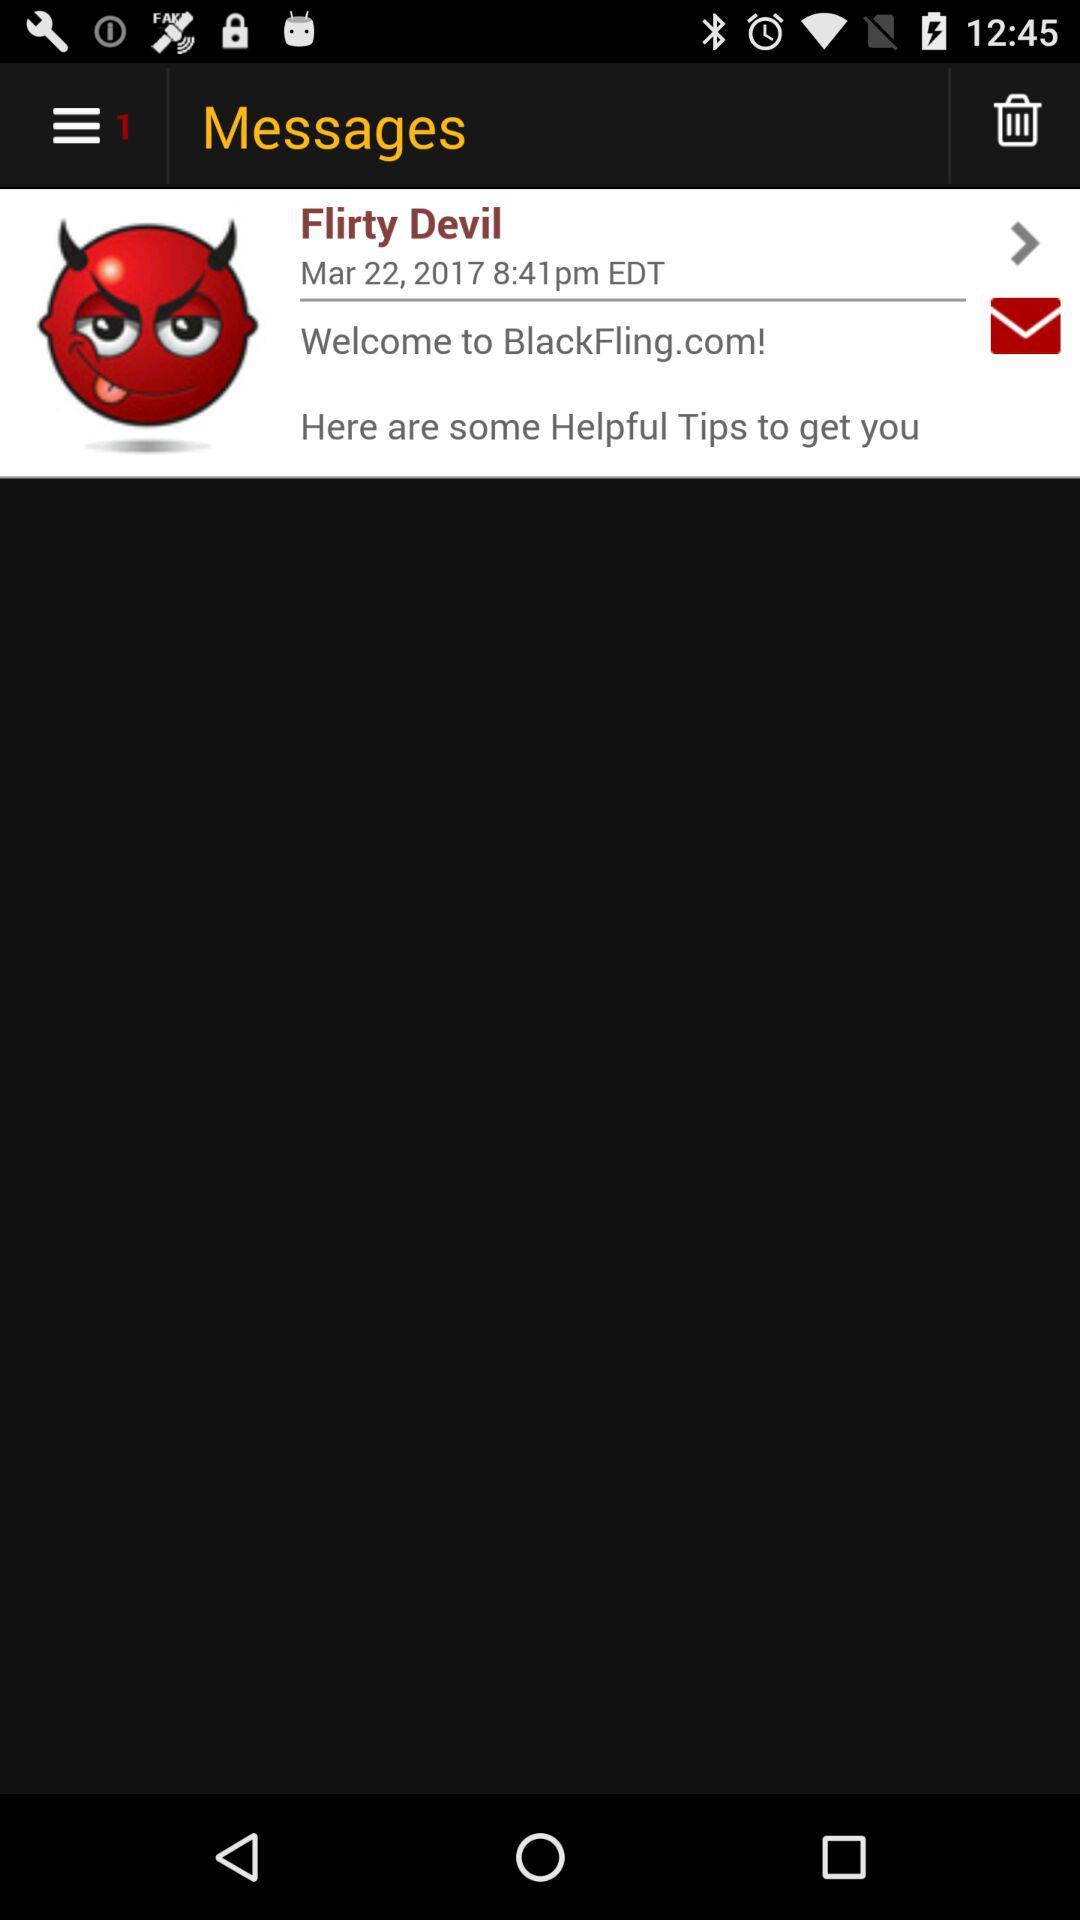What version of "Flirty Devil" is this?
When the provided information is insufficient, respond with <no answer>. <no answer> 